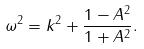Convert formula to latex. <formula><loc_0><loc_0><loc_500><loc_500>\omega ^ { 2 } = k ^ { 2 } + \frac { 1 - A ^ { 2 } } { 1 + A ^ { 2 } } .</formula> 